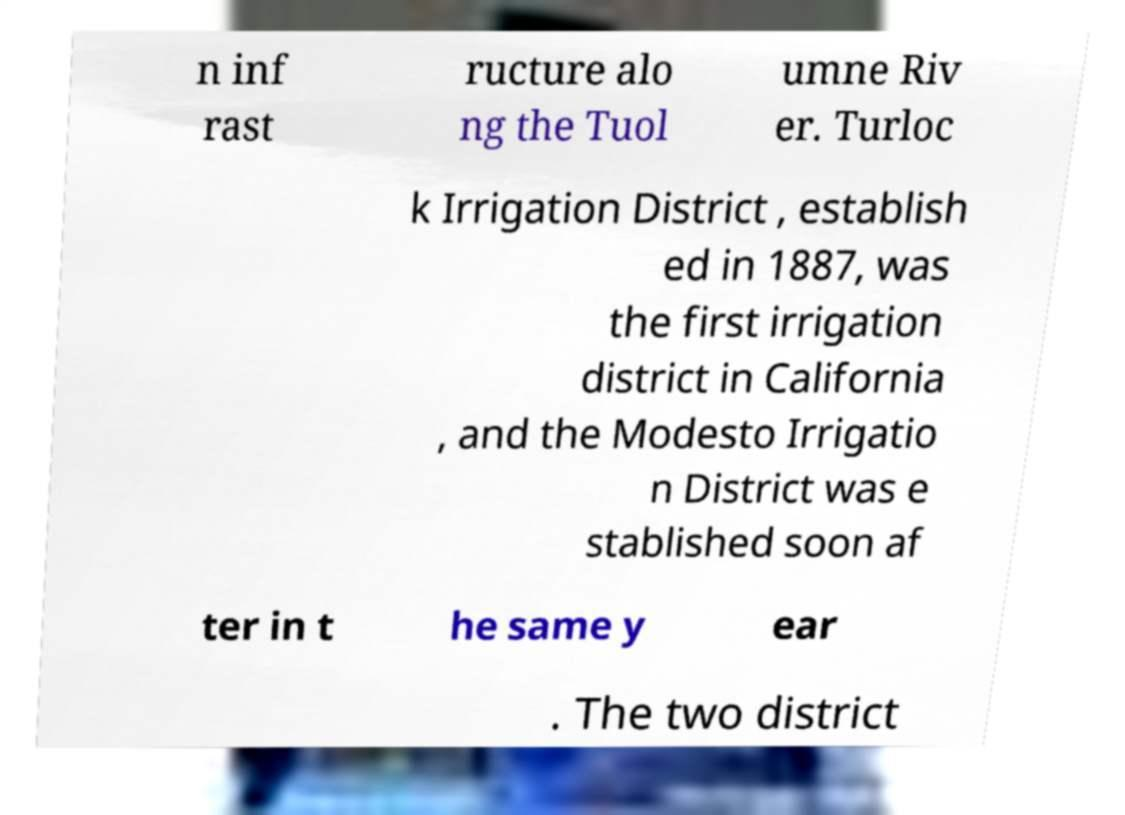What messages or text are displayed in this image? I need them in a readable, typed format. n inf rast ructure alo ng the Tuol umne Riv er. Turloc k Irrigation District , establish ed in 1887, was the first irrigation district in California , and the Modesto Irrigatio n District was e stablished soon af ter in t he same y ear . The two district 